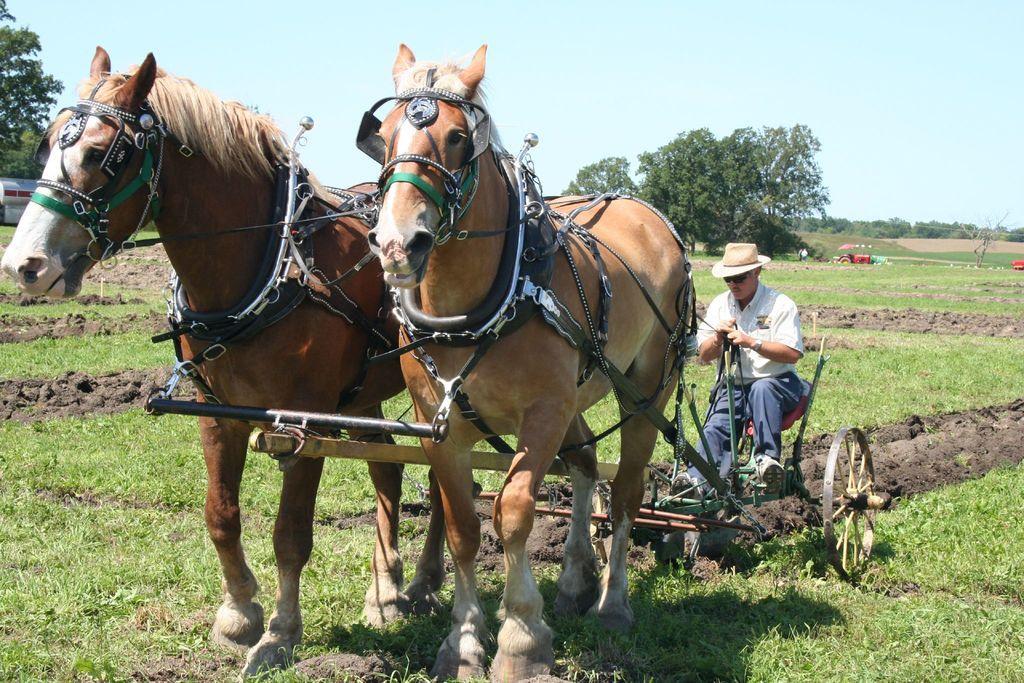How would you summarize this image in a sentence or two? In this image we can see a man riding a horse cart. We can also see a grass field, some vehicles, trees and the sky which looks cloudy. 